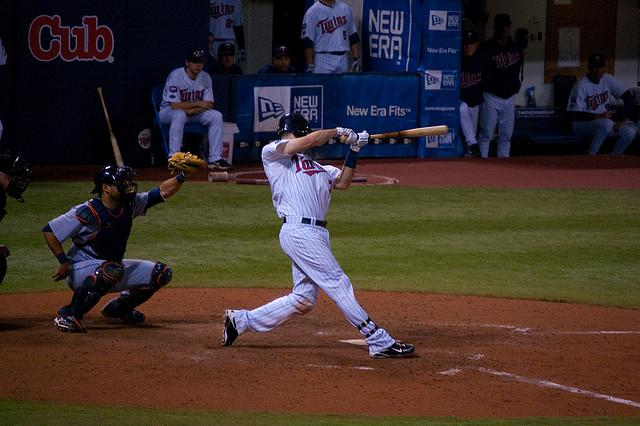What cap/apparel company is a sponsor for the stadium?

Choices:
A) new era
B) adidas
C) nike
D) cub new era 